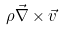<formula> <loc_0><loc_0><loc_500><loc_500>\rho \vec { \nabla } \times \vec { v }</formula> 